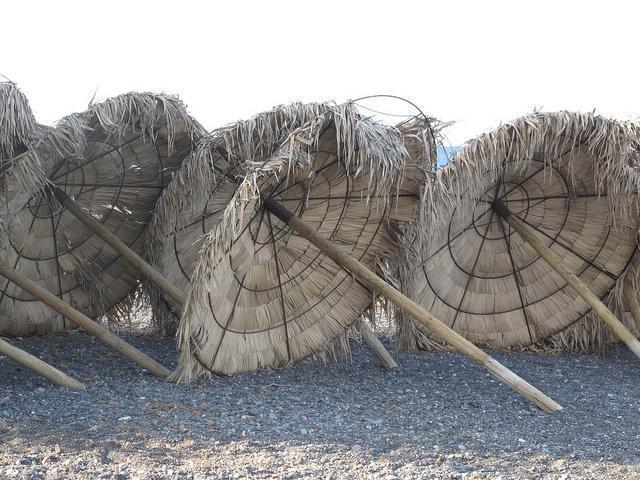What style of umbrella is seen here?
Choose the right answer from the provided options to respond to the question.
Options: Cruising, nylon, thatched, modern. Thatched. 